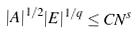Convert formula to latex. <formula><loc_0><loc_0><loc_500><loc_500>| A | ^ { 1 / 2 } | E | ^ { 1 / q } \leq C N ^ { s }</formula> 